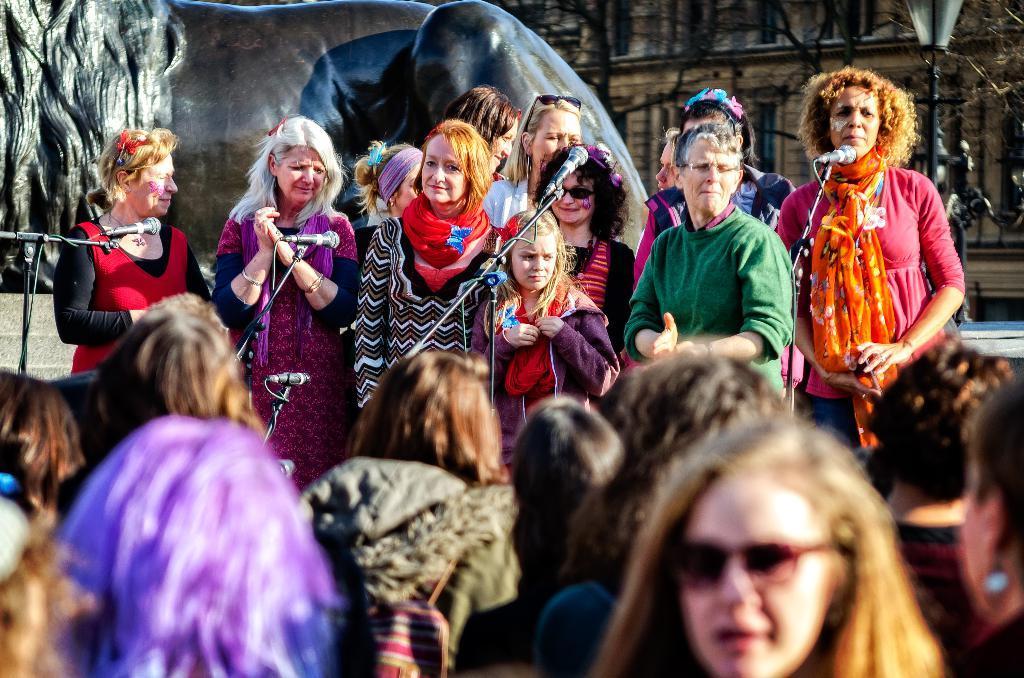Please provide a concise description of this image. In this image I can see at the back side it looks like a statue of an animal. In the middle a group of women are standing and smiling and there are microphones. On the right side there is the lamp and a building. 